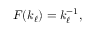<formula> <loc_0><loc_0><loc_500><loc_500>\begin{array} { r } { F ( k _ { \ell } ) = k _ { \ell } ^ { - 1 } , } \end{array}</formula> 